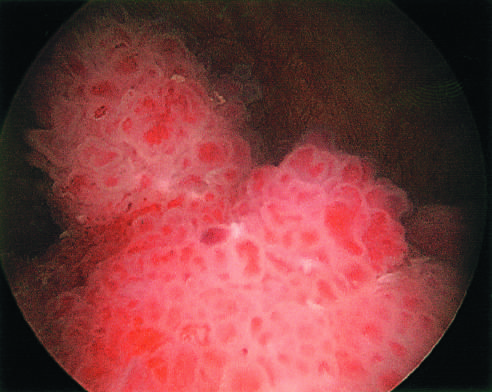what does the cystoscopic appearance of the papillary urothelial tumor resemble?
Answer the question using a single word or phrase. Resemble coral 